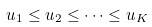Convert formula to latex. <formula><loc_0><loc_0><loc_500><loc_500>u _ { 1 } \leq u _ { 2 } \leq \dots \leq u _ { K }</formula> 